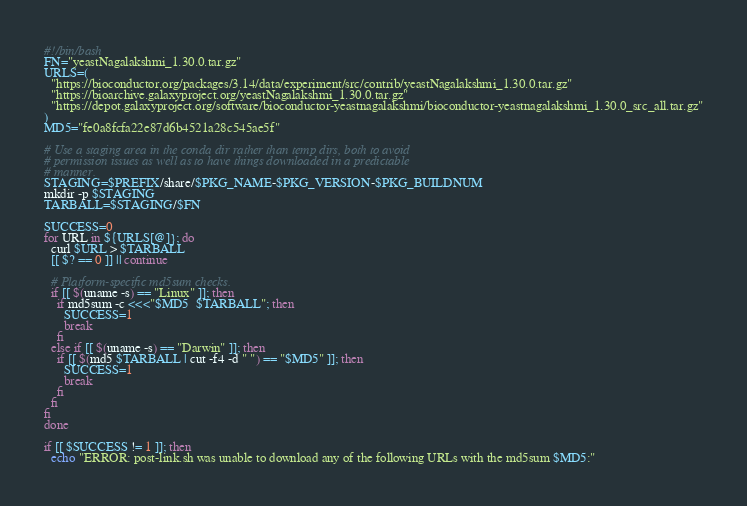<code> <loc_0><loc_0><loc_500><loc_500><_Bash_>#!/bin/bash
FN="yeastNagalakshmi_1.30.0.tar.gz"
URLS=(
  "https://bioconductor.org/packages/3.14/data/experiment/src/contrib/yeastNagalakshmi_1.30.0.tar.gz"
  "https://bioarchive.galaxyproject.org/yeastNagalakshmi_1.30.0.tar.gz"
  "https://depot.galaxyproject.org/software/bioconductor-yeastnagalakshmi/bioconductor-yeastnagalakshmi_1.30.0_src_all.tar.gz"
)
MD5="fe0a8fcfa22e87d6b4521a28c545ae5f"

# Use a staging area in the conda dir rather than temp dirs, both to avoid
# permission issues as well as to have things downloaded in a predictable
# manner.
STAGING=$PREFIX/share/$PKG_NAME-$PKG_VERSION-$PKG_BUILDNUM
mkdir -p $STAGING
TARBALL=$STAGING/$FN

SUCCESS=0
for URL in ${URLS[@]}; do
  curl $URL > $TARBALL
  [[ $? == 0 ]] || continue

  # Platform-specific md5sum checks.
  if [[ $(uname -s) == "Linux" ]]; then
    if md5sum -c <<<"$MD5  $TARBALL"; then
      SUCCESS=1
      break
    fi
  else if [[ $(uname -s) == "Darwin" ]]; then
    if [[ $(md5 $TARBALL | cut -f4 -d " ") == "$MD5" ]]; then
      SUCCESS=1
      break
    fi
  fi
fi
done

if [[ $SUCCESS != 1 ]]; then
  echo "ERROR: post-link.sh was unable to download any of the following URLs with the md5sum $MD5:"</code> 